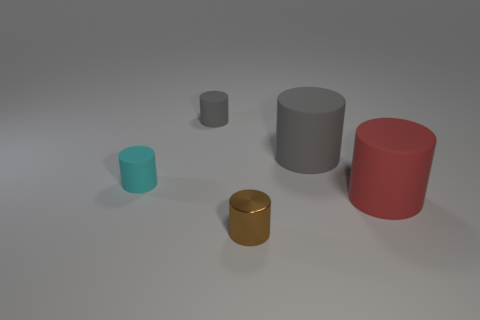The shiny cylinder in front of the big gray cylinder is what color? The shiny cylinder positioned in front of the large gray cylinder has a reflective gold color, giving it a lustrous appearance. 